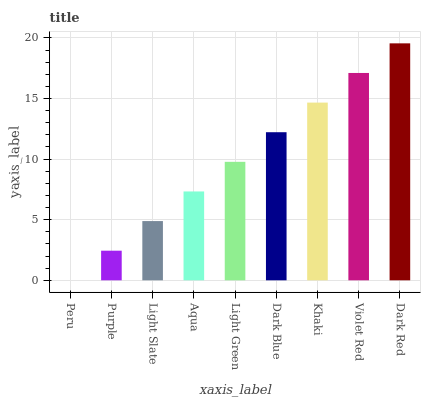Is Peru the minimum?
Answer yes or no. Yes. Is Dark Red the maximum?
Answer yes or no. Yes. Is Purple the minimum?
Answer yes or no. No. Is Purple the maximum?
Answer yes or no. No. Is Purple greater than Peru?
Answer yes or no. Yes. Is Peru less than Purple?
Answer yes or no. Yes. Is Peru greater than Purple?
Answer yes or no. No. Is Purple less than Peru?
Answer yes or no. No. Is Light Green the high median?
Answer yes or no. Yes. Is Light Green the low median?
Answer yes or no. Yes. Is Aqua the high median?
Answer yes or no. No. Is Dark Red the low median?
Answer yes or no. No. 